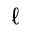Convert formula to latex. <formula><loc_0><loc_0><loc_500><loc_500>\ell</formula> 